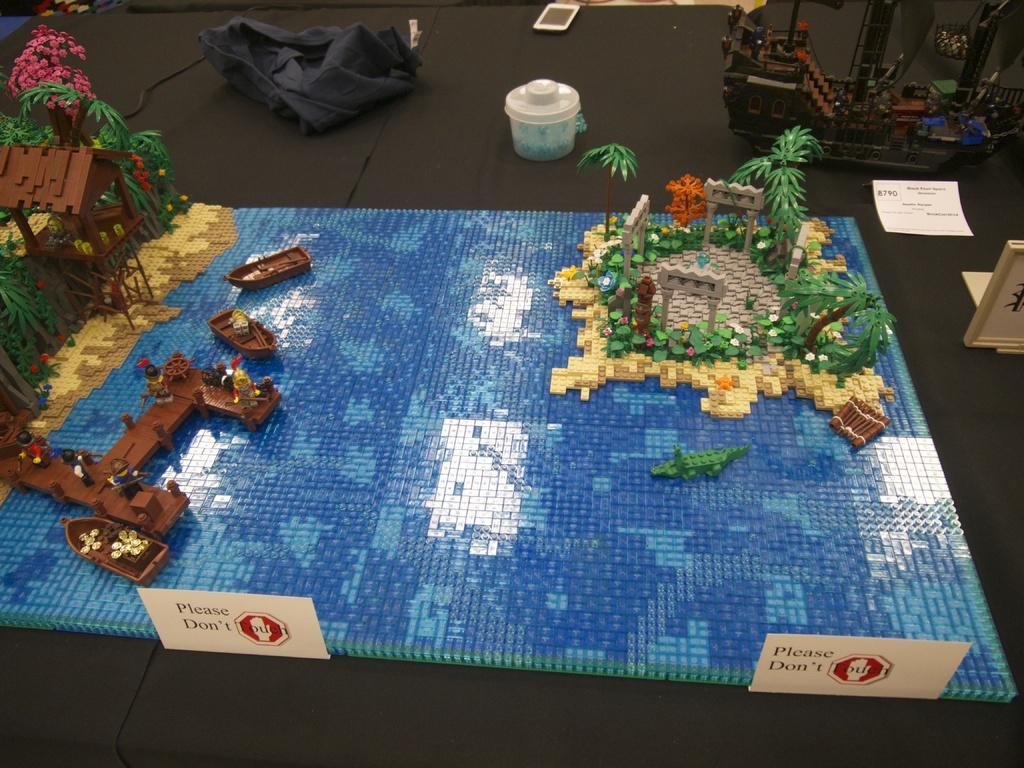Please provide a concise description of this image. In this image we can see an art is made using building blocks. Here we can see the caution boards, mobile phone and a few more objects are kept on the black color surface. 